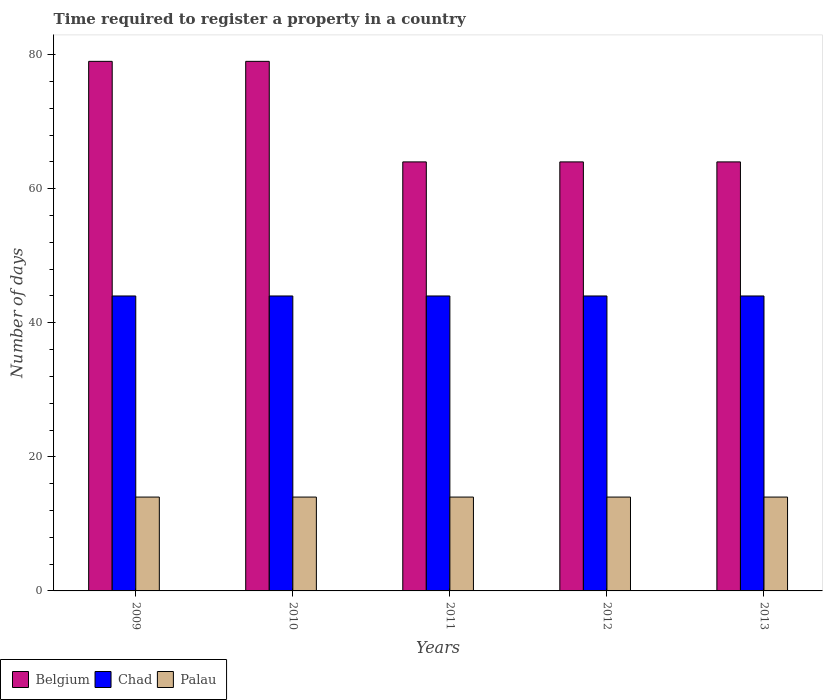How many groups of bars are there?
Offer a terse response. 5. What is the number of days required to register a property in Chad in 2011?
Give a very brief answer. 44. Across all years, what is the maximum number of days required to register a property in Chad?
Make the answer very short. 44. Across all years, what is the minimum number of days required to register a property in Palau?
Your response must be concise. 14. What is the total number of days required to register a property in Chad in the graph?
Offer a very short reply. 220. What is the difference between the number of days required to register a property in Chad in 2009 and that in 2012?
Provide a short and direct response. 0. What is the difference between the number of days required to register a property in Palau in 2009 and the number of days required to register a property in Belgium in 2012?
Give a very brief answer. -50. In the year 2009, what is the difference between the number of days required to register a property in Chad and number of days required to register a property in Palau?
Make the answer very short. 30. In how many years, is the number of days required to register a property in Belgium greater than 52 days?
Provide a short and direct response. 5. Is the number of days required to register a property in Palau in 2009 less than that in 2012?
Make the answer very short. No. Is the difference between the number of days required to register a property in Chad in 2011 and 2013 greater than the difference between the number of days required to register a property in Palau in 2011 and 2013?
Your response must be concise. No. What is the difference between the highest and the lowest number of days required to register a property in Chad?
Give a very brief answer. 0. What does the 2nd bar from the left in 2010 represents?
Offer a terse response. Chad. What does the 2nd bar from the right in 2011 represents?
Your answer should be compact. Chad. Is it the case that in every year, the sum of the number of days required to register a property in Chad and number of days required to register a property in Palau is greater than the number of days required to register a property in Belgium?
Your answer should be compact. No. How many bars are there?
Make the answer very short. 15. Are all the bars in the graph horizontal?
Give a very brief answer. No. How many years are there in the graph?
Your response must be concise. 5. Where does the legend appear in the graph?
Offer a very short reply. Bottom left. What is the title of the graph?
Provide a succinct answer. Time required to register a property in a country. Does "Seychelles" appear as one of the legend labels in the graph?
Provide a short and direct response. No. What is the label or title of the X-axis?
Give a very brief answer. Years. What is the label or title of the Y-axis?
Ensure brevity in your answer.  Number of days. What is the Number of days in Belgium in 2009?
Your answer should be compact. 79. What is the Number of days of Chad in 2009?
Provide a short and direct response. 44. What is the Number of days of Palau in 2009?
Provide a short and direct response. 14. What is the Number of days in Belgium in 2010?
Provide a succinct answer. 79. What is the Number of days of Palau in 2010?
Your response must be concise. 14. What is the Number of days in Belgium in 2011?
Make the answer very short. 64. What is the Number of days in Palau in 2011?
Keep it short and to the point. 14. What is the Number of days in Belgium in 2012?
Provide a succinct answer. 64. What is the Number of days in Palau in 2012?
Your answer should be compact. 14. What is the Number of days of Palau in 2013?
Your response must be concise. 14. Across all years, what is the maximum Number of days of Belgium?
Your response must be concise. 79. Across all years, what is the maximum Number of days in Chad?
Your answer should be very brief. 44. Across all years, what is the maximum Number of days of Palau?
Provide a succinct answer. 14. Across all years, what is the minimum Number of days of Belgium?
Your answer should be compact. 64. Across all years, what is the minimum Number of days in Chad?
Your answer should be very brief. 44. Across all years, what is the minimum Number of days in Palau?
Your answer should be very brief. 14. What is the total Number of days in Belgium in the graph?
Ensure brevity in your answer.  350. What is the total Number of days of Chad in the graph?
Your answer should be compact. 220. What is the total Number of days of Palau in the graph?
Offer a terse response. 70. What is the difference between the Number of days of Belgium in 2009 and that in 2010?
Keep it short and to the point. 0. What is the difference between the Number of days of Chad in 2009 and that in 2010?
Provide a succinct answer. 0. What is the difference between the Number of days of Belgium in 2009 and that in 2011?
Offer a very short reply. 15. What is the difference between the Number of days of Belgium in 2009 and that in 2012?
Provide a short and direct response. 15. What is the difference between the Number of days in Palau in 2009 and that in 2012?
Ensure brevity in your answer.  0. What is the difference between the Number of days in Belgium in 2009 and that in 2013?
Provide a succinct answer. 15. What is the difference between the Number of days of Chad in 2009 and that in 2013?
Your answer should be very brief. 0. What is the difference between the Number of days of Palau in 2009 and that in 2013?
Keep it short and to the point. 0. What is the difference between the Number of days of Belgium in 2010 and that in 2011?
Your response must be concise. 15. What is the difference between the Number of days of Chad in 2010 and that in 2011?
Keep it short and to the point. 0. What is the difference between the Number of days of Belgium in 2010 and that in 2012?
Your response must be concise. 15. What is the difference between the Number of days in Chad in 2010 and that in 2012?
Give a very brief answer. 0. What is the difference between the Number of days in Palau in 2010 and that in 2012?
Ensure brevity in your answer.  0. What is the difference between the Number of days in Chad in 2010 and that in 2013?
Your answer should be compact. 0. What is the difference between the Number of days in Palau in 2010 and that in 2013?
Provide a succinct answer. 0. What is the difference between the Number of days of Chad in 2011 and that in 2012?
Your answer should be very brief. 0. What is the difference between the Number of days in Palau in 2011 and that in 2012?
Ensure brevity in your answer.  0. What is the difference between the Number of days in Belgium in 2012 and that in 2013?
Your answer should be very brief. 0. What is the difference between the Number of days in Chad in 2012 and that in 2013?
Your answer should be very brief. 0. What is the difference between the Number of days in Palau in 2012 and that in 2013?
Offer a very short reply. 0. What is the difference between the Number of days of Belgium in 2009 and the Number of days of Palau in 2010?
Offer a very short reply. 65. What is the difference between the Number of days in Chad in 2009 and the Number of days in Palau in 2010?
Your answer should be compact. 30. What is the difference between the Number of days in Belgium in 2009 and the Number of days in Chad in 2011?
Provide a short and direct response. 35. What is the difference between the Number of days in Chad in 2009 and the Number of days in Palau in 2011?
Provide a short and direct response. 30. What is the difference between the Number of days of Belgium in 2009 and the Number of days of Chad in 2012?
Keep it short and to the point. 35. What is the difference between the Number of days of Belgium in 2010 and the Number of days of Chad in 2011?
Make the answer very short. 35. What is the difference between the Number of days of Belgium in 2010 and the Number of days of Palau in 2011?
Keep it short and to the point. 65. What is the difference between the Number of days of Chad in 2010 and the Number of days of Palau in 2011?
Ensure brevity in your answer.  30. What is the difference between the Number of days in Chad in 2010 and the Number of days in Palau in 2012?
Keep it short and to the point. 30. What is the difference between the Number of days in Belgium in 2010 and the Number of days in Chad in 2013?
Provide a short and direct response. 35. What is the difference between the Number of days in Belgium in 2011 and the Number of days in Chad in 2012?
Make the answer very short. 20. What is the difference between the Number of days of Belgium in 2011 and the Number of days of Palau in 2012?
Keep it short and to the point. 50. What is the difference between the Number of days of Chad in 2011 and the Number of days of Palau in 2012?
Your answer should be compact. 30. What is the difference between the Number of days in Chad in 2011 and the Number of days in Palau in 2013?
Keep it short and to the point. 30. What is the average Number of days of Belgium per year?
Offer a very short reply. 70. What is the average Number of days in Chad per year?
Keep it short and to the point. 44. In the year 2009, what is the difference between the Number of days of Belgium and Number of days of Chad?
Your answer should be compact. 35. In the year 2010, what is the difference between the Number of days of Belgium and Number of days of Palau?
Give a very brief answer. 65. In the year 2010, what is the difference between the Number of days in Chad and Number of days in Palau?
Offer a very short reply. 30. In the year 2011, what is the difference between the Number of days of Belgium and Number of days of Chad?
Keep it short and to the point. 20. In the year 2012, what is the difference between the Number of days of Belgium and Number of days of Palau?
Make the answer very short. 50. What is the ratio of the Number of days in Belgium in 2009 to that in 2010?
Your response must be concise. 1. What is the ratio of the Number of days in Chad in 2009 to that in 2010?
Offer a very short reply. 1. What is the ratio of the Number of days in Belgium in 2009 to that in 2011?
Your answer should be very brief. 1.23. What is the ratio of the Number of days in Palau in 2009 to that in 2011?
Keep it short and to the point. 1. What is the ratio of the Number of days in Belgium in 2009 to that in 2012?
Your answer should be compact. 1.23. What is the ratio of the Number of days of Belgium in 2009 to that in 2013?
Offer a terse response. 1.23. What is the ratio of the Number of days of Belgium in 2010 to that in 2011?
Make the answer very short. 1.23. What is the ratio of the Number of days of Chad in 2010 to that in 2011?
Ensure brevity in your answer.  1. What is the ratio of the Number of days in Belgium in 2010 to that in 2012?
Your answer should be very brief. 1.23. What is the ratio of the Number of days in Belgium in 2010 to that in 2013?
Your answer should be compact. 1.23. What is the ratio of the Number of days in Palau in 2010 to that in 2013?
Your response must be concise. 1. What is the ratio of the Number of days in Belgium in 2011 to that in 2012?
Give a very brief answer. 1. What is the ratio of the Number of days of Chad in 2011 to that in 2012?
Keep it short and to the point. 1. What is the ratio of the Number of days of Palau in 2011 to that in 2012?
Offer a terse response. 1. What is the ratio of the Number of days of Palau in 2011 to that in 2013?
Make the answer very short. 1. What is the ratio of the Number of days of Belgium in 2012 to that in 2013?
Your answer should be compact. 1. What is the ratio of the Number of days of Chad in 2012 to that in 2013?
Offer a terse response. 1. What is the ratio of the Number of days in Palau in 2012 to that in 2013?
Offer a very short reply. 1. What is the difference between the highest and the second highest Number of days of Belgium?
Your response must be concise. 0. What is the difference between the highest and the second highest Number of days in Chad?
Your response must be concise. 0. What is the difference between the highest and the second highest Number of days in Palau?
Offer a very short reply. 0. What is the difference between the highest and the lowest Number of days in Belgium?
Offer a terse response. 15. 